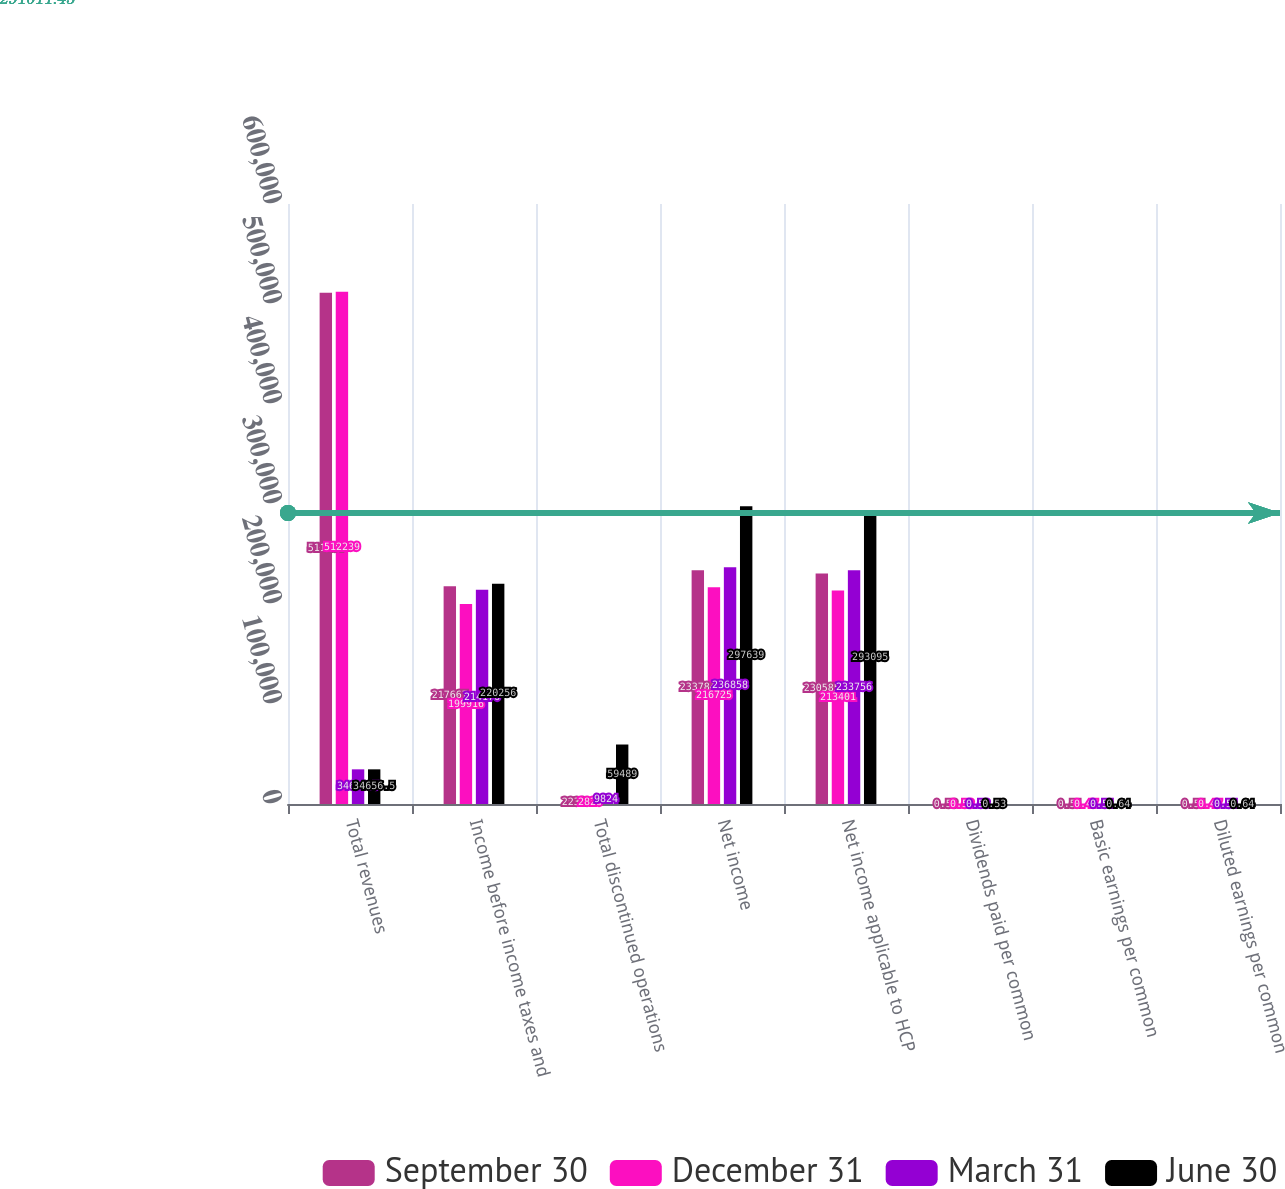<chart> <loc_0><loc_0><loc_500><loc_500><stacked_bar_chart><ecel><fcel>Total revenues<fcel>Income before income taxes and<fcel>Total discontinued operations<fcel>Net income<fcel>Net income applicable to HCP<fcel>Dividends paid per common<fcel>Basic earnings per common<fcel>Diluted earnings per common<nl><fcel>September 30<fcel>511184<fcel>217667<fcel>2232<fcel>233784<fcel>230585<fcel>0.53<fcel>0.51<fcel>0.51<nl><fcel>December 31<fcel>512239<fcel>199916<fcel>2828<fcel>216725<fcel>213401<fcel>0.53<fcel>0.47<fcel>0.47<nl><fcel>March 31<fcel>34656.5<fcel>214176<fcel>9824<fcel>236858<fcel>233756<fcel>0.53<fcel>0.51<fcel>0.51<nl><fcel>June 30<fcel>34656.5<fcel>220256<fcel>59489<fcel>297639<fcel>293095<fcel>0.53<fcel>0.64<fcel>0.64<nl></chart> 